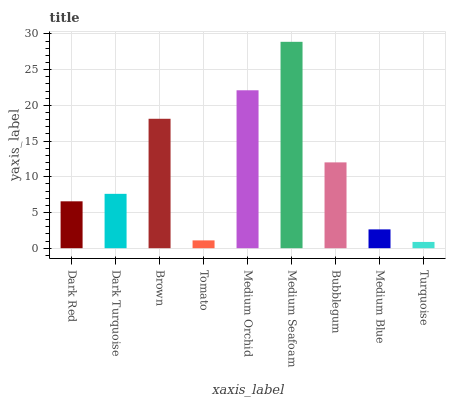Is Turquoise the minimum?
Answer yes or no. Yes. Is Medium Seafoam the maximum?
Answer yes or no. Yes. Is Dark Turquoise the minimum?
Answer yes or no. No. Is Dark Turquoise the maximum?
Answer yes or no. No. Is Dark Turquoise greater than Dark Red?
Answer yes or no. Yes. Is Dark Red less than Dark Turquoise?
Answer yes or no. Yes. Is Dark Red greater than Dark Turquoise?
Answer yes or no. No. Is Dark Turquoise less than Dark Red?
Answer yes or no. No. Is Dark Turquoise the high median?
Answer yes or no. Yes. Is Dark Turquoise the low median?
Answer yes or no. Yes. Is Dark Red the high median?
Answer yes or no. No. Is Bubblegum the low median?
Answer yes or no. No. 